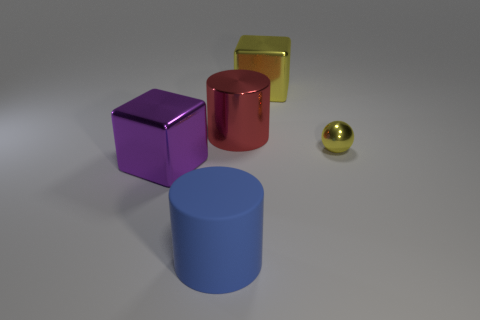Add 3 large yellow metallic cubes. How many objects exist? 8 Subtract all blocks. How many objects are left? 3 Add 4 large rubber things. How many large rubber things are left? 5 Add 5 large cubes. How many large cubes exist? 7 Subtract 0 purple cylinders. How many objects are left? 5 Subtract all small spheres. Subtract all tiny metal objects. How many objects are left? 3 